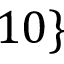Convert formula to latex. <formula><loc_0><loc_0><loc_500><loc_500>1 0 \}</formula> 